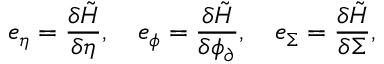Convert formula to latex. <formula><loc_0><loc_0><loc_500><loc_500>e _ { \eta } = \frac { \delta \tilde { H } } { \delta \eta } , \quad e _ { \phi } = \frac { \delta \tilde { H } } { \delta \phi _ { \partial } } , \quad e _ { \Sigma } = \frac { \delta \tilde { H } } { \delta \Sigma } ,</formula> 